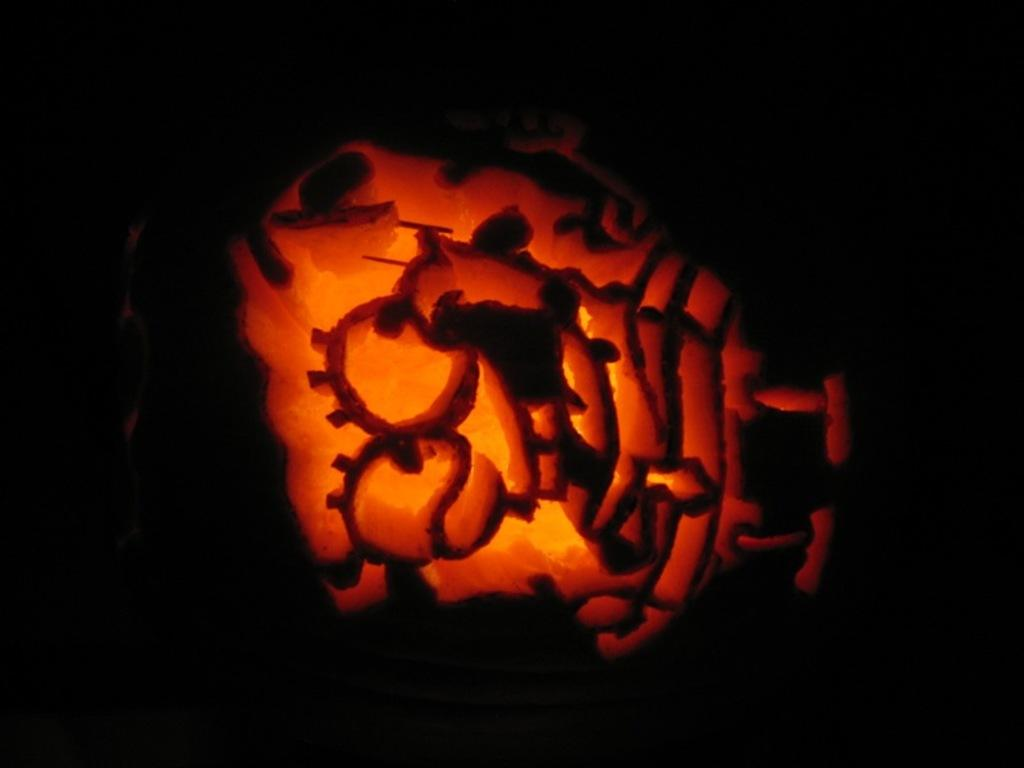What is the main subject in the middle of the image? There is a cartoon image in the middle of the image. Can you describe the background of the image? The background of the image is dark. What type of underwear is the cartoon character wearing in the image? There is no underwear visible in the image, as it features a cartoon character and not a person. 